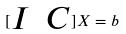Convert formula to latex. <formula><loc_0><loc_0><loc_500><loc_500>[ \begin{matrix} I & C \end{matrix} ] X = b</formula> 